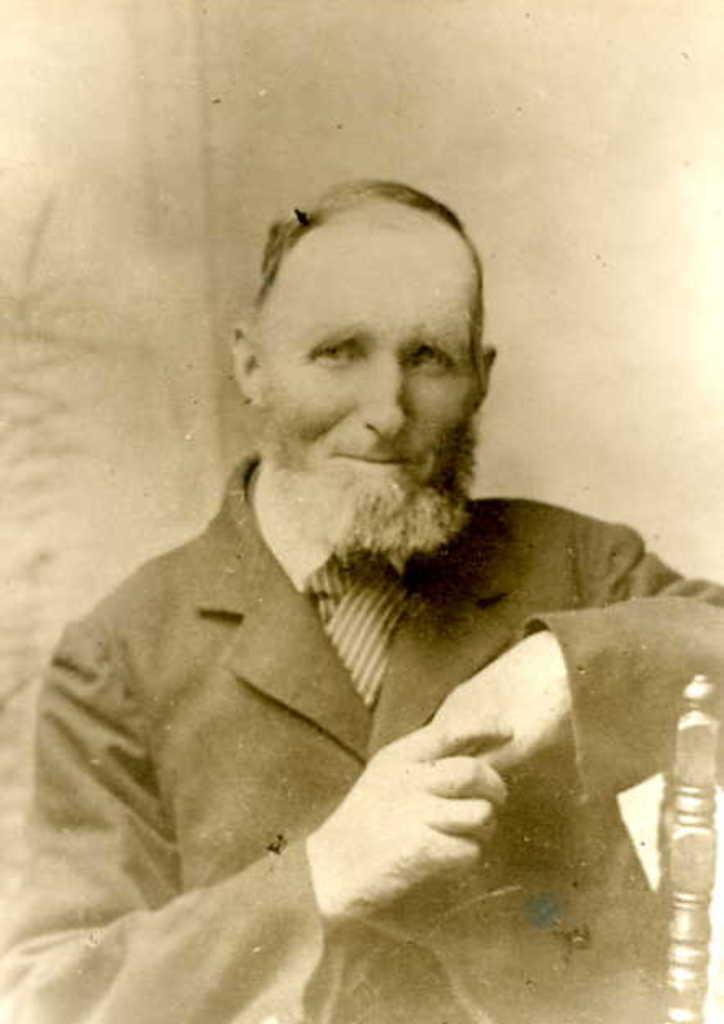In one or two sentences, can you explain what this image depicts? In this image I can see the person and the image is in black and white. 